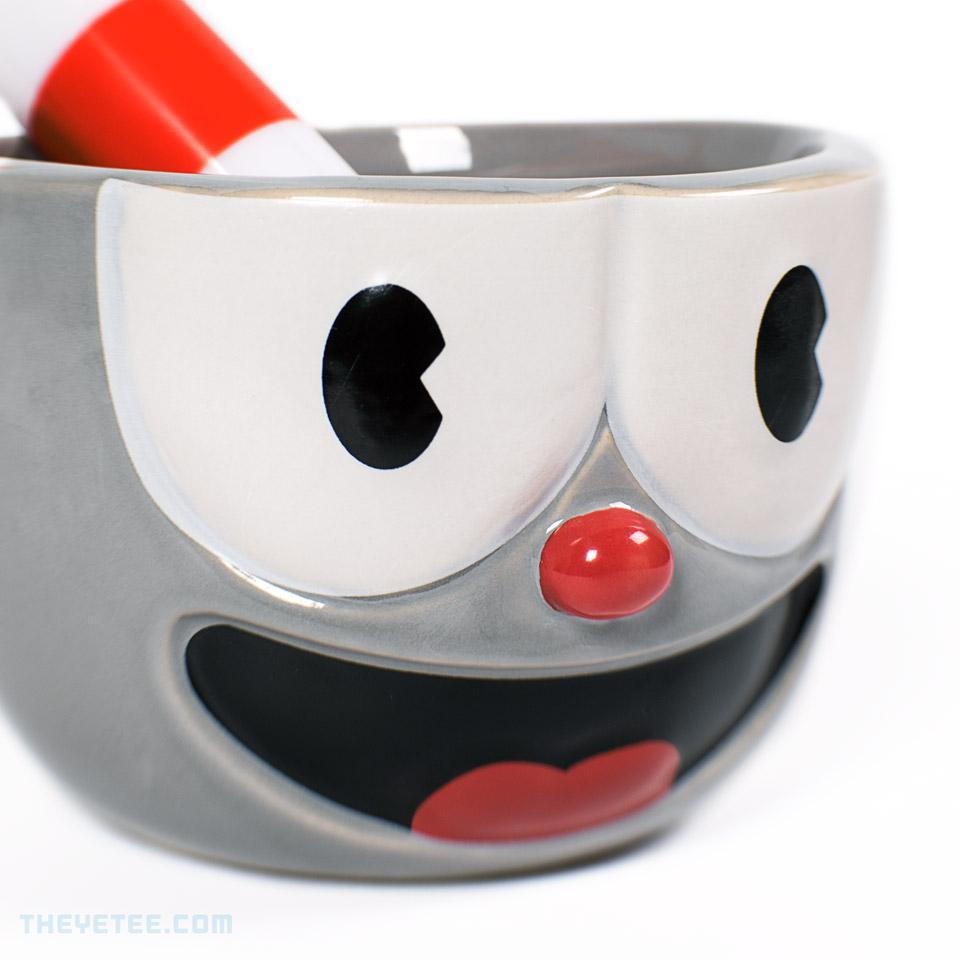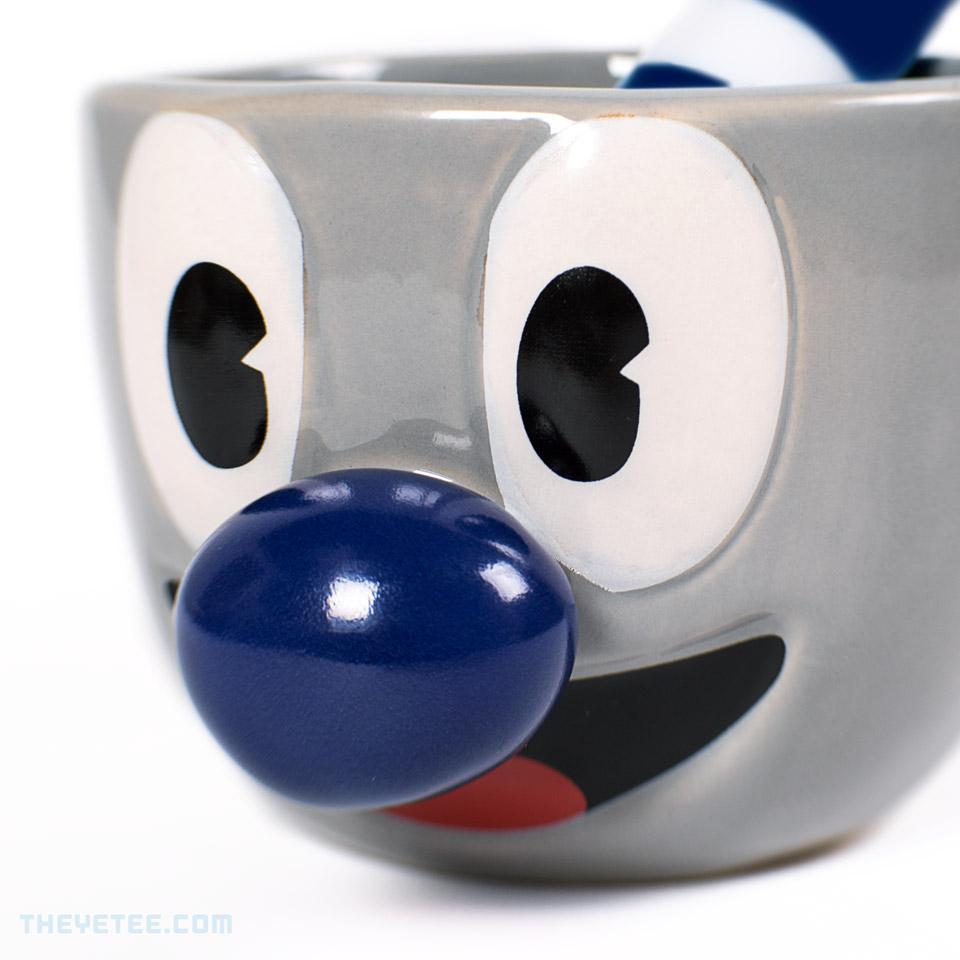The first image is the image on the left, the second image is the image on the right. Assess this claim about the two images: "An equal number of cups with a face design are in each image, a fat striped straw in each cup.". Correct or not? Answer yes or no. Yes. 